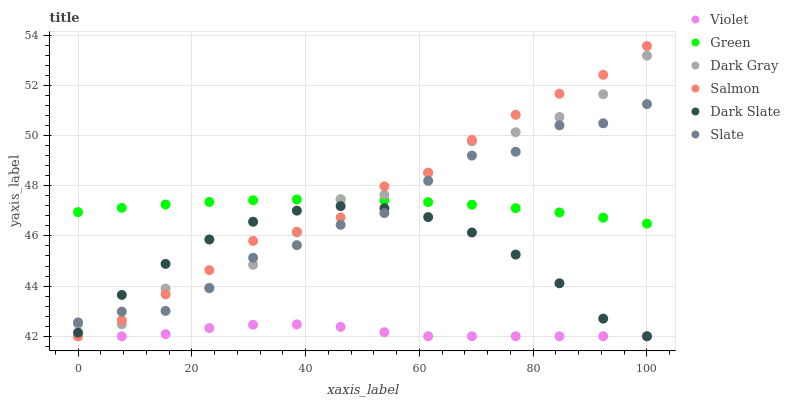Does Violet have the minimum area under the curve?
Answer yes or no. Yes. Does Salmon have the maximum area under the curve?
Answer yes or no. Yes. Does Dark Gray have the minimum area under the curve?
Answer yes or no. No. Does Dark Gray have the maximum area under the curve?
Answer yes or no. No. Is Green the smoothest?
Answer yes or no. Yes. Is Dark Gray the roughest?
Answer yes or no. Yes. Is Salmon the smoothest?
Answer yes or no. No. Is Salmon the roughest?
Answer yes or no. No. Does Salmon have the lowest value?
Answer yes or no. Yes. Does Dark Gray have the lowest value?
Answer yes or no. No. Does Salmon have the highest value?
Answer yes or no. Yes. Does Dark Gray have the highest value?
Answer yes or no. No. Is Violet less than Dark Gray?
Answer yes or no. Yes. Is Green greater than Dark Slate?
Answer yes or no. Yes. Does Green intersect Salmon?
Answer yes or no. Yes. Is Green less than Salmon?
Answer yes or no. No. Is Green greater than Salmon?
Answer yes or no. No. Does Violet intersect Dark Gray?
Answer yes or no. No. 